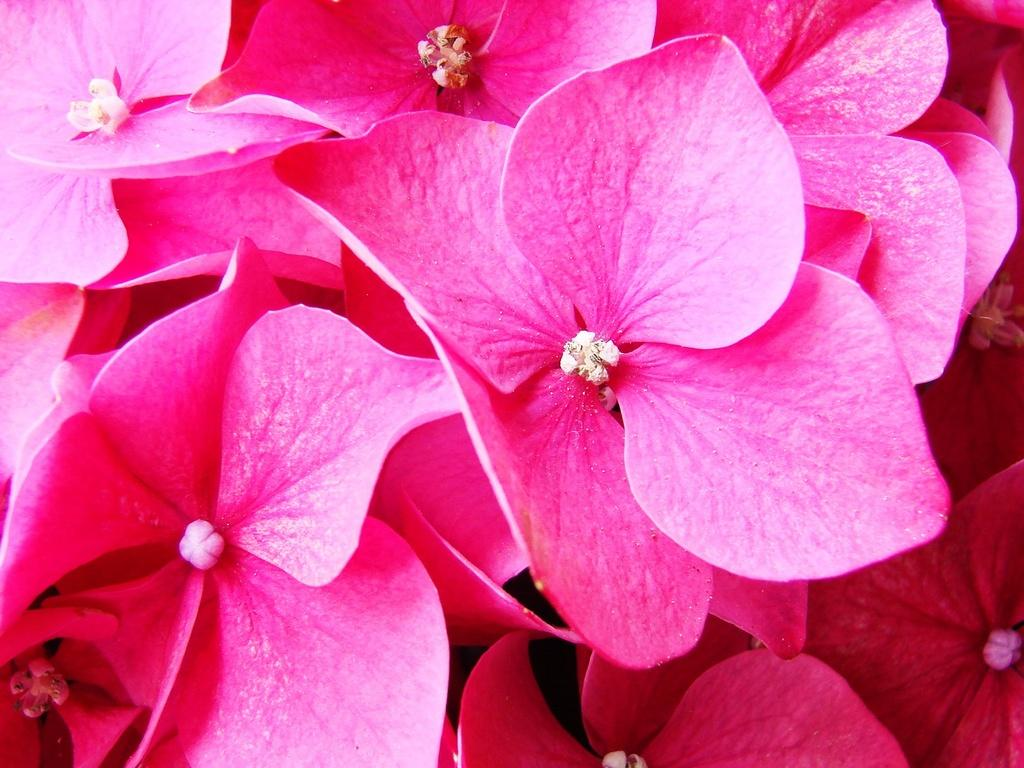What is the dominant color of the flowers in the image? The dominant color of the flowers in the image is pink. How many flowers can be seen in the image? The image shows many pink color flowers. What might be the type of flowers based on their color? Based on their color, the flowers could be pink roses, carnations, or other pink flowers. What type of oatmeal is being served in the alley next to the flowers? There is no oatmeal or alley present in the image; it only shows many pink color flowers. 